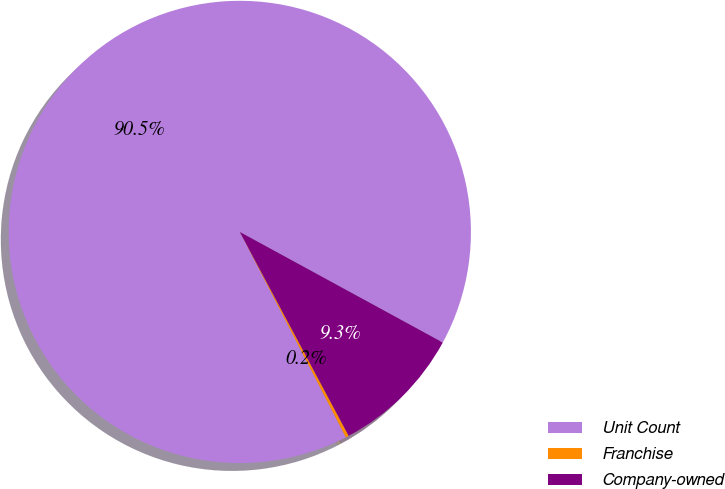Convert chart. <chart><loc_0><loc_0><loc_500><loc_500><pie_chart><fcel>Unit Count<fcel>Franchise<fcel>Company-owned<nl><fcel>90.52%<fcel>0.22%<fcel>9.25%<nl></chart> 